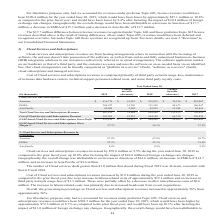According to Opentext Corporation's financial document, Where are Cloud services and subscriptions revenues from? hosting arrangements where in connection with the licensing of software, the end user doesn’t take possession of the software, as well as from end-to-end fully outsourced business-to-business (B2B) integration solutions to our customers (collectively referred to as cloud arrangements). The document states: "Cloud services and subscriptions revenues are from hosting arrangements where in connection with the licensing of software, the end user doesn’t take ..." Also, What is Cost of Cloud services and subscriptions revenues comprised primarily of? third party network usage fees, maintenance of in-house data hardware centers, technical support personnel-related costs, and some third party royalty costs.. The document states: "d subscriptions revenues is comprised primarily of third party network usage fees, maintenance of in-house data hardware centers, technical support pe..." Also, What years are included in the table? The document contains multiple relevant values: 2019, 2018, 2017. From the document: "Change increase (decrease) 2017 e been $390.4 million for the year ended June 30, 2019, which would have been lower by approximately $47.1 million or ..." Also, can you calculate: What is the average GAAP-based Cloud Services and Subscriptions Gross Margin %? To answer this question, I need to perform calculations using the financial data. The calculation is: (57.7+56.1+57.5)/3, which equals 57.1 (percentage). This is based on the information: "ices and Subscriptions Gross Margin % 57.7% 56.1% 57.5% d Cloud Services and Subscriptions Gross Margin % 57.7% 56.1% 57.5% d Services and Subscriptions Gross Margin % 57.7% 56.1% 57.5%..." The key data points involved are: 56.1, 57.5, 57.7. Also, can you calculate: What is the percentage increase in the Cloud Services and Subscriptions for Americas for 2018 to 2019? Based on the calculation: 61,553/555,223, the result is 11.09 (percentage). This is based on the information: "Americas $ 616,776 $ 61,553 $ 555,223 $ 70,216 $ 485,007 Americas $ 616,776 $ 61,553 $ 555,223 $ 70,216 $ 485,007..." The key data points involved are: 555,223, 61,553. Also, can you calculate: What is the average annual GAAP-based Cloud Services and Subscriptions Gross Profit for the 3 years? To answer this question, I need to perform calculations using the financial data. The calculation is: (523,819+464,808+405,645)/3, which equals 464757.33 (in thousands). This is based on the information: "d Subscriptions Gross Profit $ 523,819 $ 59,011 $ 464,808 $ 59,163 $ 405,645 ss Profit $ 523,819 $ 59,011 $ 464,808 $ 59,163 $ 405,645 d Cloud Services and Subscriptions Gross Profit $ 523,819 $ 59,01..." The key data points involved are: 405,645, 464,808, 523,819. 